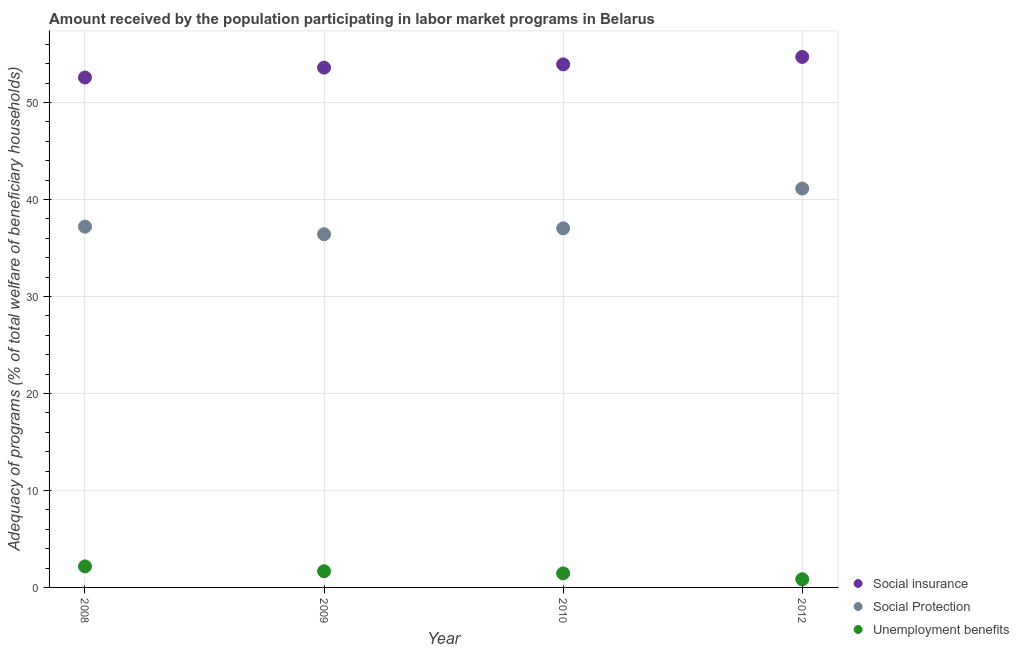How many different coloured dotlines are there?
Make the answer very short. 3. Is the number of dotlines equal to the number of legend labels?
Offer a terse response. Yes. What is the amount received by the population participating in social insurance programs in 2012?
Your answer should be very brief. 54.7. Across all years, what is the maximum amount received by the population participating in unemployment benefits programs?
Your answer should be very brief. 2.17. Across all years, what is the minimum amount received by the population participating in unemployment benefits programs?
Provide a short and direct response. 0.84. In which year was the amount received by the population participating in unemployment benefits programs minimum?
Offer a terse response. 2012. What is the total amount received by the population participating in unemployment benefits programs in the graph?
Provide a succinct answer. 6.13. What is the difference between the amount received by the population participating in social protection programs in 2009 and that in 2010?
Your answer should be compact. -0.61. What is the difference between the amount received by the population participating in unemployment benefits programs in 2010 and the amount received by the population participating in social insurance programs in 2008?
Give a very brief answer. -51.13. What is the average amount received by the population participating in social protection programs per year?
Provide a succinct answer. 37.94. In the year 2010, what is the difference between the amount received by the population participating in social insurance programs and amount received by the population participating in unemployment benefits programs?
Provide a short and direct response. 52.48. In how many years, is the amount received by the population participating in social insurance programs greater than 54 %?
Your answer should be compact. 1. What is the ratio of the amount received by the population participating in social protection programs in 2009 to that in 2010?
Keep it short and to the point. 0.98. Is the amount received by the population participating in unemployment benefits programs in 2008 less than that in 2012?
Offer a terse response. No. What is the difference between the highest and the second highest amount received by the population participating in unemployment benefits programs?
Your response must be concise. 0.5. What is the difference between the highest and the lowest amount received by the population participating in social insurance programs?
Give a very brief answer. 2.12. In how many years, is the amount received by the population participating in unemployment benefits programs greater than the average amount received by the population participating in unemployment benefits programs taken over all years?
Ensure brevity in your answer.  2. Is the sum of the amount received by the population participating in unemployment benefits programs in 2008 and 2010 greater than the maximum amount received by the population participating in social insurance programs across all years?
Your response must be concise. No. Is it the case that in every year, the sum of the amount received by the population participating in social insurance programs and amount received by the population participating in social protection programs is greater than the amount received by the population participating in unemployment benefits programs?
Keep it short and to the point. Yes. Does the amount received by the population participating in social protection programs monotonically increase over the years?
Make the answer very short. No. Is the amount received by the population participating in social protection programs strictly greater than the amount received by the population participating in social insurance programs over the years?
Keep it short and to the point. No. Is the amount received by the population participating in social protection programs strictly less than the amount received by the population participating in unemployment benefits programs over the years?
Provide a succinct answer. No. How many dotlines are there?
Offer a terse response. 3. How many years are there in the graph?
Your answer should be very brief. 4. What is the difference between two consecutive major ticks on the Y-axis?
Provide a succinct answer. 10. Are the values on the major ticks of Y-axis written in scientific E-notation?
Offer a very short reply. No. Where does the legend appear in the graph?
Your answer should be compact. Bottom right. How are the legend labels stacked?
Provide a succinct answer. Vertical. What is the title of the graph?
Offer a terse response. Amount received by the population participating in labor market programs in Belarus. Does "New Zealand" appear as one of the legend labels in the graph?
Offer a terse response. No. What is the label or title of the Y-axis?
Give a very brief answer. Adequacy of programs (% of total welfare of beneficiary households). What is the Adequacy of programs (% of total welfare of beneficiary households) in Social insurance in 2008?
Offer a very short reply. 52.58. What is the Adequacy of programs (% of total welfare of beneficiary households) in Social Protection in 2008?
Ensure brevity in your answer.  37.2. What is the Adequacy of programs (% of total welfare of beneficiary households) of Unemployment benefits in 2008?
Provide a short and direct response. 2.17. What is the Adequacy of programs (% of total welfare of beneficiary households) in Social insurance in 2009?
Make the answer very short. 53.6. What is the Adequacy of programs (% of total welfare of beneficiary households) in Social Protection in 2009?
Provide a short and direct response. 36.42. What is the Adequacy of programs (% of total welfare of beneficiary households) in Unemployment benefits in 2009?
Provide a short and direct response. 1.67. What is the Adequacy of programs (% of total welfare of beneficiary households) of Social insurance in 2010?
Offer a very short reply. 53.93. What is the Adequacy of programs (% of total welfare of beneficiary households) of Social Protection in 2010?
Your answer should be compact. 37.03. What is the Adequacy of programs (% of total welfare of beneficiary households) in Unemployment benefits in 2010?
Your answer should be very brief. 1.45. What is the Adequacy of programs (% of total welfare of beneficiary households) of Social insurance in 2012?
Offer a very short reply. 54.7. What is the Adequacy of programs (% of total welfare of beneficiary households) of Social Protection in 2012?
Provide a short and direct response. 41.13. What is the Adequacy of programs (% of total welfare of beneficiary households) in Unemployment benefits in 2012?
Ensure brevity in your answer.  0.84. Across all years, what is the maximum Adequacy of programs (% of total welfare of beneficiary households) in Social insurance?
Provide a short and direct response. 54.7. Across all years, what is the maximum Adequacy of programs (% of total welfare of beneficiary households) in Social Protection?
Ensure brevity in your answer.  41.13. Across all years, what is the maximum Adequacy of programs (% of total welfare of beneficiary households) in Unemployment benefits?
Keep it short and to the point. 2.17. Across all years, what is the minimum Adequacy of programs (% of total welfare of beneficiary households) of Social insurance?
Your answer should be compact. 52.58. Across all years, what is the minimum Adequacy of programs (% of total welfare of beneficiary households) in Social Protection?
Offer a terse response. 36.42. Across all years, what is the minimum Adequacy of programs (% of total welfare of beneficiary households) in Unemployment benefits?
Keep it short and to the point. 0.84. What is the total Adequacy of programs (% of total welfare of beneficiary households) in Social insurance in the graph?
Provide a succinct answer. 214.81. What is the total Adequacy of programs (% of total welfare of beneficiary households) of Social Protection in the graph?
Offer a very short reply. 151.77. What is the total Adequacy of programs (% of total welfare of beneficiary households) of Unemployment benefits in the graph?
Ensure brevity in your answer.  6.13. What is the difference between the Adequacy of programs (% of total welfare of beneficiary households) in Social insurance in 2008 and that in 2009?
Ensure brevity in your answer.  -1.02. What is the difference between the Adequacy of programs (% of total welfare of beneficiary households) of Social Protection in 2008 and that in 2009?
Offer a very short reply. 0.78. What is the difference between the Adequacy of programs (% of total welfare of beneficiary households) of Unemployment benefits in 2008 and that in 2009?
Make the answer very short. 0.5. What is the difference between the Adequacy of programs (% of total welfare of beneficiary households) of Social insurance in 2008 and that in 2010?
Your answer should be very brief. -1.35. What is the difference between the Adequacy of programs (% of total welfare of beneficiary households) of Social Protection in 2008 and that in 2010?
Offer a terse response. 0.18. What is the difference between the Adequacy of programs (% of total welfare of beneficiary households) in Unemployment benefits in 2008 and that in 2010?
Make the answer very short. 0.72. What is the difference between the Adequacy of programs (% of total welfare of beneficiary households) of Social insurance in 2008 and that in 2012?
Provide a short and direct response. -2.12. What is the difference between the Adequacy of programs (% of total welfare of beneficiary households) in Social Protection in 2008 and that in 2012?
Your answer should be compact. -3.93. What is the difference between the Adequacy of programs (% of total welfare of beneficiary households) in Unemployment benefits in 2008 and that in 2012?
Keep it short and to the point. 1.33. What is the difference between the Adequacy of programs (% of total welfare of beneficiary households) of Social insurance in 2009 and that in 2010?
Give a very brief answer. -0.34. What is the difference between the Adequacy of programs (% of total welfare of beneficiary households) in Social Protection in 2009 and that in 2010?
Ensure brevity in your answer.  -0.61. What is the difference between the Adequacy of programs (% of total welfare of beneficiary households) of Unemployment benefits in 2009 and that in 2010?
Your answer should be compact. 0.22. What is the difference between the Adequacy of programs (% of total welfare of beneficiary households) of Social insurance in 2009 and that in 2012?
Offer a very short reply. -1.1. What is the difference between the Adequacy of programs (% of total welfare of beneficiary households) of Social Protection in 2009 and that in 2012?
Offer a very short reply. -4.71. What is the difference between the Adequacy of programs (% of total welfare of beneficiary households) of Unemployment benefits in 2009 and that in 2012?
Keep it short and to the point. 0.83. What is the difference between the Adequacy of programs (% of total welfare of beneficiary households) in Social insurance in 2010 and that in 2012?
Your answer should be compact. -0.77. What is the difference between the Adequacy of programs (% of total welfare of beneficiary households) of Social Protection in 2010 and that in 2012?
Your answer should be compact. -4.1. What is the difference between the Adequacy of programs (% of total welfare of beneficiary households) of Unemployment benefits in 2010 and that in 2012?
Offer a very short reply. 0.61. What is the difference between the Adequacy of programs (% of total welfare of beneficiary households) of Social insurance in 2008 and the Adequacy of programs (% of total welfare of beneficiary households) of Social Protection in 2009?
Provide a succinct answer. 16.16. What is the difference between the Adequacy of programs (% of total welfare of beneficiary households) in Social insurance in 2008 and the Adequacy of programs (% of total welfare of beneficiary households) in Unemployment benefits in 2009?
Offer a terse response. 50.91. What is the difference between the Adequacy of programs (% of total welfare of beneficiary households) of Social Protection in 2008 and the Adequacy of programs (% of total welfare of beneficiary households) of Unemployment benefits in 2009?
Ensure brevity in your answer.  35.53. What is the difference between the Adequacy of programs (% of total welfare of beneficiary households) of Social insurance in 2008 and the Adequacy of programs (% of total welfare of beneficiary households) of Social Protection in 2010?
Ensure brevity in your answer.  15.55. What is the difference between the Adequacy of programs (% of total welfare of beneficiary households) of Social insurance in 2008 and the Adequacy of programs (% of total welfare of beneficiary households) of Unemployment benefits in 2010?
Make the answer very short. 51.13. What is the difference between the Adequacy of programs (% of total welfare of beneficiary households) in Social Protection in 2008 and the Adequacy of programs (% of total welfare of beneficiary households) in Unemployment benefits in 2010?
Provide a short and direct response. 35.75. What is the difference between the Adequacy of programs (% of total welfare of beneficiary households) in Social insurance in 2008 and the Adequacy of programs (% of total welfare of beneficiary households) in Social Protection in 2012?
Make the answer very short. 11.45. What is the difference between the Adequacy of programs (% of total welfare of beneficiary households) of Social insurance in 2008 and the Adequacy of programs (% of total welfare of beneficiary households) of Unemployment benefits in 2012?
Provide a short and direct response. 51.74. What is the difference between the Adequacy of programs (% of total welfare of beneficiary households) of Social Protection in 2008 and the Adequacy of programs (% of total welfare of beneficiary households) of Unemployment benefits in 2012?
Provide a short and direct response. 36.36. What is the difference between the Adequacy of programs (% of total welfare of beneficiary households) in Social insurance in 2009 and the Adequacy of programs (% of total welfare of beneficiary households) in Social Protection in 2010?
Your response must be concise. 16.57. What is the difference between the Adequacy of programs (% of total welfare of beneficiary households) of Social insurance in 2009 and the Adequacy of programs (% of total welfare of beneficiary households) of Unemployment benefits in 2010?
Make the answer very short. 52.15. What is the difference between the Adequacy of programs (% of total welfare of beneficiary households) of Social Protection in 2009 and the Adequacy of programs (% of total welfare of beneficiary households) of Unemployment benefits in 2010?
Keep it short and to the point. 34.97. What is the difference between the Adequacy of programs (% of total welfare of beneficiary households) of Social insurance in 2009 and the Adequacy of programs (% of total welfare of beneficiary households) of Social Protection in 2012?
Offer a very short reply. 12.47. What is the difference between the Adequacy of programs (% of total welfare of beneficiary households) of Social insurance in 2009 and the Adequacy of programs (% of total welfare of beneficiary households) of Unemployment benefits in 2012?
Provide a short and direct response. 52.76. What is the difference between the Adequacy of programs (% of total welfare of beneficiary households) in Social Protection in 2009 and the Adequacy of programs (% of total welfare of beneficiary households) in Unemployment benefits in 2012?
Your answer should be very brief. 35.58. What is the difference between the Adequacy of programs (% of total welfare of beneficiary households) in Social insurance in 2010 and the Adequacy of programs (% of total welfare of beneficiary households) in Social Protection in 2012?
Offer a very short reply. 12.8. What is the difference between the Adequacy of programs (% of total welfare of beneficiary households) in Social insurance in 2010 and the Adequacy of programs (% of total welfare of beneficiary households) in Unemployment benefits in 2012?
Keep it short and to the point. 53.09. What is the difference between the Adequacy of programs (% of total welfare of beneficiary households) in Social Protection in 2010 and the Adequacy of programs (% of total welfare of beneficiary households) in Unemployment benefits in 2012?
Offer a terse response. 36.18. What is the average Adequacy of programs (% of total welfare of beneficiary households) in Social insurance per year?
Ensure brevity in your answer.  53.7. What is the average Adequacy of programs (% of total welfare of beneficiary households) in Social Protection per year?
Ensure brevity in your answer.  37.94. What is the average Adequacy of programs (% of total welfare of beneficiary households) of Unemployment benefits per year?
Provide a short and direct response. 1.53. In the year 2008, what is the difference between the Adequacy of programs (% of total welfare of beneficiary households) in Social insurance and Adequacy of programs (% of total welfare of beneficiary households) in Social Protection?
Give a very brief answer. 15.38. In the year 2008, what is the difference between the Adequacy of programs (% of total welfare of beneficiary households) of Social insurance and Adequacy of programs (% of total welfare of beneficiary households) of Unemployment benefits?
Make the answer very short. 50.41. In the year 2008, what is the difference between the Adequacy of programs (% of total welfare of beneficiary households) in Social Protection and Adequacy of programs (% of total welfare of beneficiary households) in Unemployment benefits?
Offer a very short reply. 35.03. In the year 2009, what is the difference between the Adequacy of programs (% of total welfare of beneficiary households) of Social insurance and Adequacy of programs (% of total welfare of beneficiary households) of Social Protection?
Provide a short and direct response. 17.18. In the year 2009, what is the difference between the Adequacy of programs (% of total welfare of beneficiary households) in Social insurance and Adequacy of programs (% of total welfare of beneficiary households) in Unemployment benefits?
Offer a terse response. 51.93. In the year 2009, what is the difference between the Adequacy of programs (% of total welfare of beneficiary households) in Social Protection and Adequacy of programs (% of total welfare of beneficiary households) in Unemployment benefits?
Provide a short and direct response. 34.75. In the year 2010, what is the difference between the Adequacy of programs (% of total welfare of beneficiary households) in Social insurance and Adequacy of programs (% of total welfare of beneficiary households) in Social Protection?
Offer a very short reply. 16.91. In the year 2010, what is the difference between the Adequacy of programs (% of total welfare of beneficiary households) of Social insurance and Adequacy of programs (% of total welfare of beneficiary households) of Unemployment benefits?
Keep it short and to the point. 52.48. In the year 2010, what is the difference between the Adequacy of programs (% of total welfare of beneficiary households) of Social Protection and Adequacy of programs (% of total welfare of beneficiary households) of Unemployment benefits?
Keep it short and to the point. 35.58. In the year 2012, what is the difference between the Adequacy of programs (% of total welfare of beneficiary households) in Social insurance and Adequacy of programs (% of total welfare of beneficiary households) in Social Protection?
Offer a very short reply. 13.57. In the year 2012, what is the difference between the Adequacy of programs (% of total welfare of beneficiary households) of Social insurance and Adequacy of programs (% of total welfare of beneficiary households) of Unemployment benefits?
Ensure brevity in your answer.  53.86. In the year 2012, what is the difference between the Adequacy of programs (% of total welfare of beneficiary households) of Social Protection and Adequacy of programs (% of total welfare of beneficiary households) of Unemployment benefits?
Provide a short and direct response. 40.29. What is the ratio of the Adequacy of programs (% of total welfare of beneficiary households) of Social Protection in 2008 to that in 2009?
Ensure brevity in your answer.  1.02. What is the ratio of the Adequacy of programs (% of total welfare of beneficiary households) of Unemployment benefits in 2008 to that in 2009?
Give a very brief answer. 1.3. What is the ratio of the Adequacy of programs (% of total welfare of beneficiary households) of Social insurance in 2008 to that in 2010?
Offer a terse response. 0.97. What is the ratio of the Adequacy of programs (% of total welfare of beneficiary households) in Social Protection in 2008 to that in 2010?
Keep it short and to the point. 1. What is the ratio of the Adequacy of programs (% of total welfare of beneficiary households) of Unemployment benefits in 2008 to that in 2010?
Give a very brief answer. 1.5. What is the ratio of the Adequacy of programs (% of total welfare of beneficiary households) of Social insurance in 2008 to that in 2012?
Your answer should be compact. 0.96. What is the ratio of the Adequacy of programs (% of total welfare of beneficiary households) in Social Protection in 2008 to that in 2012?
Provide a short and direct response. 0.9. What is the ratio of the Adequacy of programs (% of total welfare of beneficiary households) of Unemployment benefits in 2008 to that in 2012?
Your answer should be compact. 2.58. What is the ratio of the Adequacy of programs (% of total welfare of beneficiary households) of Social Protection in 2009 to that in 2010?
Your answer should be very brief. 0.98. What is the ratio of the Adequacy of programs (% of total welfare of beneficiary households) in Unemployment benefits in 2009 to that in 2010?
Offer a very short reply. 1.15. What is the ratio of the Adequacy of programs (% of total welfare of beneficiary households) of Social insurance in 2009 to that in 2012?
Your answer should be compact. 0.98. What is the ratio of the Adequacy of programs (% of total welfare of beneficiary households) of Social Protection in 2009 to that in 2012?
Make the answer very short. 0.89. What is the ratio of the Adequacy of programs (% of total welfare of beneficiary households) in Unemployment benefits in 2009 to that in 2012?
Your answer should be very brief. 1.98. What is the ratio of the Adequacy of programs (% of total welfare of beneficiary households) of Social insurance in 2010 to that in 2012?
Provide a short and direct response. 0.99. What is the ratio of the Adequacy of programs (% of total welfare of beneficiary households) in Social Protection in 2010 to that in 2012?
Make the answer very short. 0.9. What is the ratio of the Adequacy of programs (% of total welfare of beneficiary households) in Unemployment benefits in 2010 to that in 2012?
Provide a succinct answer. 1.72. What is the difference between the highest and the second highest Adequacy of programs (% of total welfare of beneficiary households) of Social insurance?
Offer a very short reply. 0.77. What is the difference between the highest and the second highest Adequacy of programs (% of total welfare of beneficiary households) of Social Protection?
Keep it short and to the point. 3.93. What is the difference between the highest and the second highest Adequacy of programs (% of total welfare of beneficiary households) of Unemployment benefits?
Your response must be concise. 0.5. What is the difference between the highest and the lowest Adequacy of programs (% of total welfare of beneficiary households) of Social insurance?
Keep it short and to the point. 2.12. What is the difference between the highest and the lowest Adequacy of programs (% of total welfare of beneficiary households) of Social Protection?
Ensure brevity in your answer.  4.71. What is the difference between the highest and the lowest Adequacy of programs (% of total welfare of beneficiary households) of Unemployment benefits?
Your answer should be very brief. 1.33. 